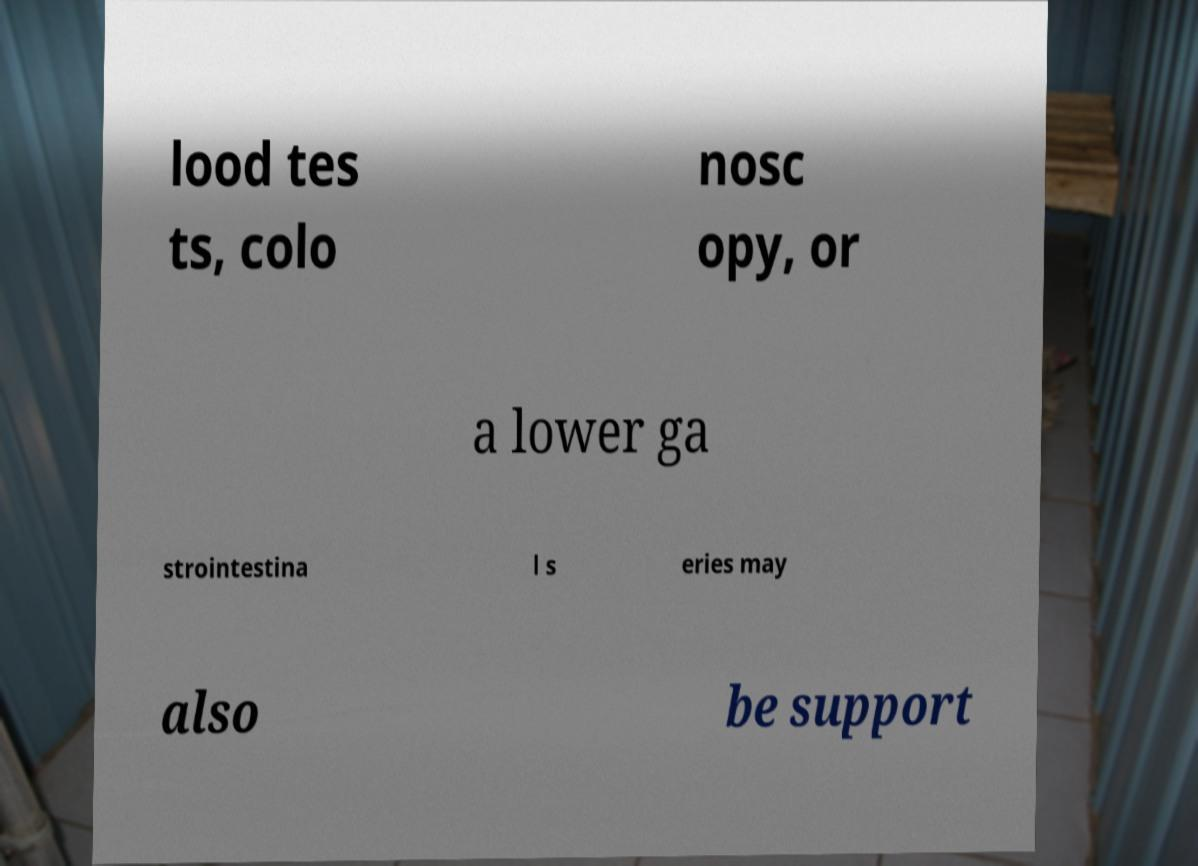Can you accurately transcribe the text from the provided image for me? lood tes ts, colo nosc opy, or a lower ga strointestina l s eries may also be support 